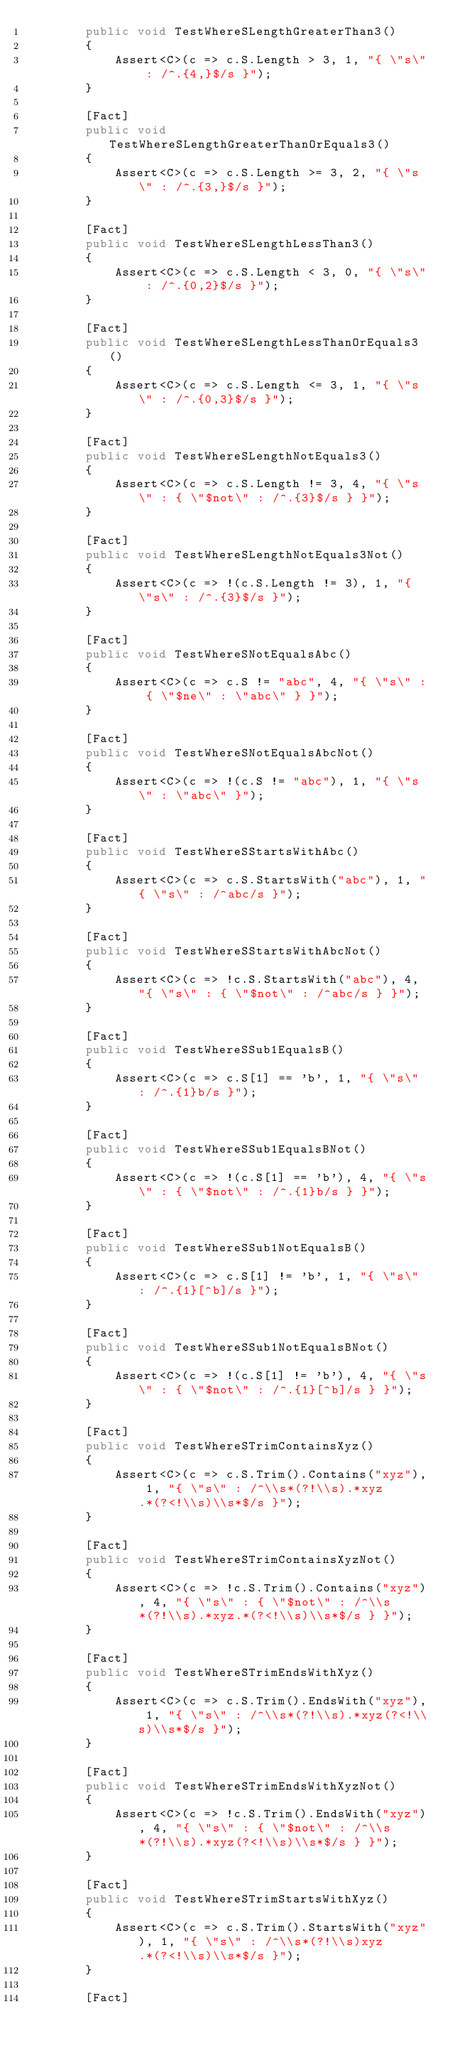Convert code to text. <code><loc_0><loc_0><loc_500><loc_500><_C#_>        public void TestWhereSLengthGreaterThan3()
        {
            Assert<C>(c => c.S.Length > 3, 1, "{ \"s\" : /^.{4,}$/s }");
        }

        [Fact]
        public void TestWhereSLengthGreaterThanOrEquals3()
        {
            Assert<C>(c => c.S.Length >= 3, 2, "{ \"s\" : /^.{3,}$/s }");
        }

        [Fact]
        public void TestWhereSLengthLessThan3()
        {
            Assert<C>(c => c.S.Length < 3, 0, "{ \"s\" : /^.{0,2}$/s }");
        }

        [Fact]
        public void TestWhereSLengthLessThanOrEquals3()
        {
            Assert<C>(c => c.S.Length <= 3, 1, "{ \"s\" : /^.{0,3}$/s }");
        }

        [Fact]
        public void TestWhereSLengthNotEquals3()
        {
            Assert<C>(c => c.S.Length != 3, 4, "{ \"s\" : { \"$not\" : /^.{3}$/s } }");
        }

        [Fact]
        public void TestWhereSLengthNotEquals3Not()
        {
            Assert<C>(c => !(c.S.Length != 3), 1, "{ \"s\" : /^.{3}$/s }");
        }

        [Fact]
        public void TestWhereSNotEqualsAbc()
        {
            Assert<C>(c => c.S != "abc", 4, "{ \"s\" : { \"$ne\" : \"abc\" } }");
        }

        [Fact]
        public void TestWhereSNotEqualsAbcNot()
        {
            Assert<C>(c => !(c.S != "abc"), 1, "{ \"s\" : \"abc\" }");
        }

        [Fact]
        public void TestWhereSStartsWithAbc()
        {
            Assert<C>(c => c.S.StartsWith("abc"), 1, "{ \"s\" : /^abc/s }");
        }

        [Fact]
        public void TestWhereSStartsWithAbcNot()
        {
            Assert<C>(c => !c.S.StartsWith("abc"), 4, "{ \"s\" : { \"$not\" : /^abc/s } }");
        }

        [Fact]
        public void TestWhereSSub1EqualsB()
        {
            Assert<C>(c => c.S[1] == 'b', 1, "{ \"s\" : /^.{1}b/s }");
        }

        [Fact]
        public void TestWhereSSub1EqualsBNot()
        {
            Assert<C>(c => !(c.S[1] == 'b'), 4, "{ \"s\" : { \"$not\" : /^.{1}b/s } }");
        }

        [Fact]
        public void TestWhereSSub1NotEqualsB()
        {
            Assert<C>(c => c.S[1] != 'b', 1, "{ \"s\" : /^.{1}[^b]/s }");
        }

        [Fact]
        public void TestWhereSSub1NotEqualsBNot()
        {
            Assert<C>(c => !(c.S[1] != 'b'), 4, "{ \"s\" : { \"$not\" : /^.{1}[^b]/s } }");
        }

        [Fact]
        public void TestWhereSTrimContainsXyz()
        {
            Assert<C>(c => c.S.Trim().Contains("xyz"), 1, "{ \"s\" : /^\\s*(?!\\s).*xyz.*(?<!\\s)\\s*$/s }");
        }

        [Fact]
        public void TestWhereSTrimContainsXyzNot()
        {
            Assert<C>(c => !c.S.Trim().Contains("xyz"), 4, "{ \"s\" : { \"$not\" : /^\\s*(?!\\s).*xyz.*(?<!\\s)\\s*$/s } }");
        }

        [Fact]
        public void TestWhereSTrimEndsWithXyz()
        {
            Assert<C>(c => c.S.Trim().EndsWith("xyz"), 1, "{ \"s\" : /^\\s*(?!\\s).*xyz(?<!\\s)\\s*$/s }");
        }

        [Fact]
        public void TestWhereSTrimEndsWithXyzNot()
        {
            Assert<C>(c => !c.S.Trim().EndsWith("xyz"), 4, "{ \"s\" : { \"$not\" : /^\\s*(?!\\s).*xyz(?<!\\s)\\s*$/s } }");
        }

        [Fact]
        public void TestWhereSTrimStartsWithXyz()
        {
            Assert<C>(c => c.S.Trim().StartsWith("xyz"), 1, "{ \"s\" : /^\\s*(?!\\s)xyz.*(?<!\\s)\\s*$/s }");
        }

        [Fact]</code> 